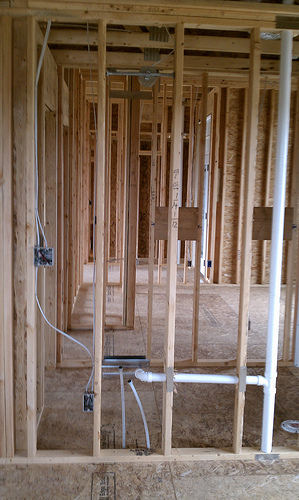<image>
Is the pipe in the floor? No. The pipe is not contained within the floor. These objects have a different spatial relationship. 